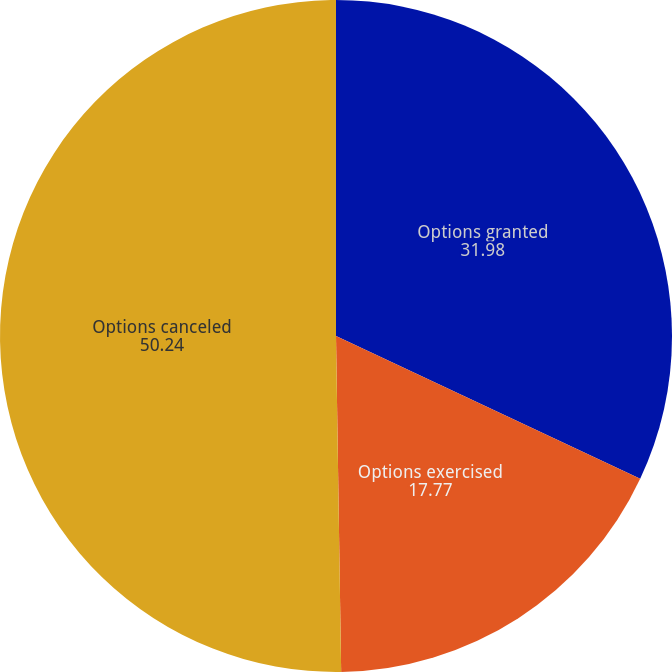Convert chart to OTSL. <chart><loc_0><loc_0><loc_500><loc_500><pie_chart><fcel>Options granted<fcel>Options exercised<fcel>Options canceled<nl><fcel>31.98%<fcel>17.77%<fcel>50.24%<nl></chart> 